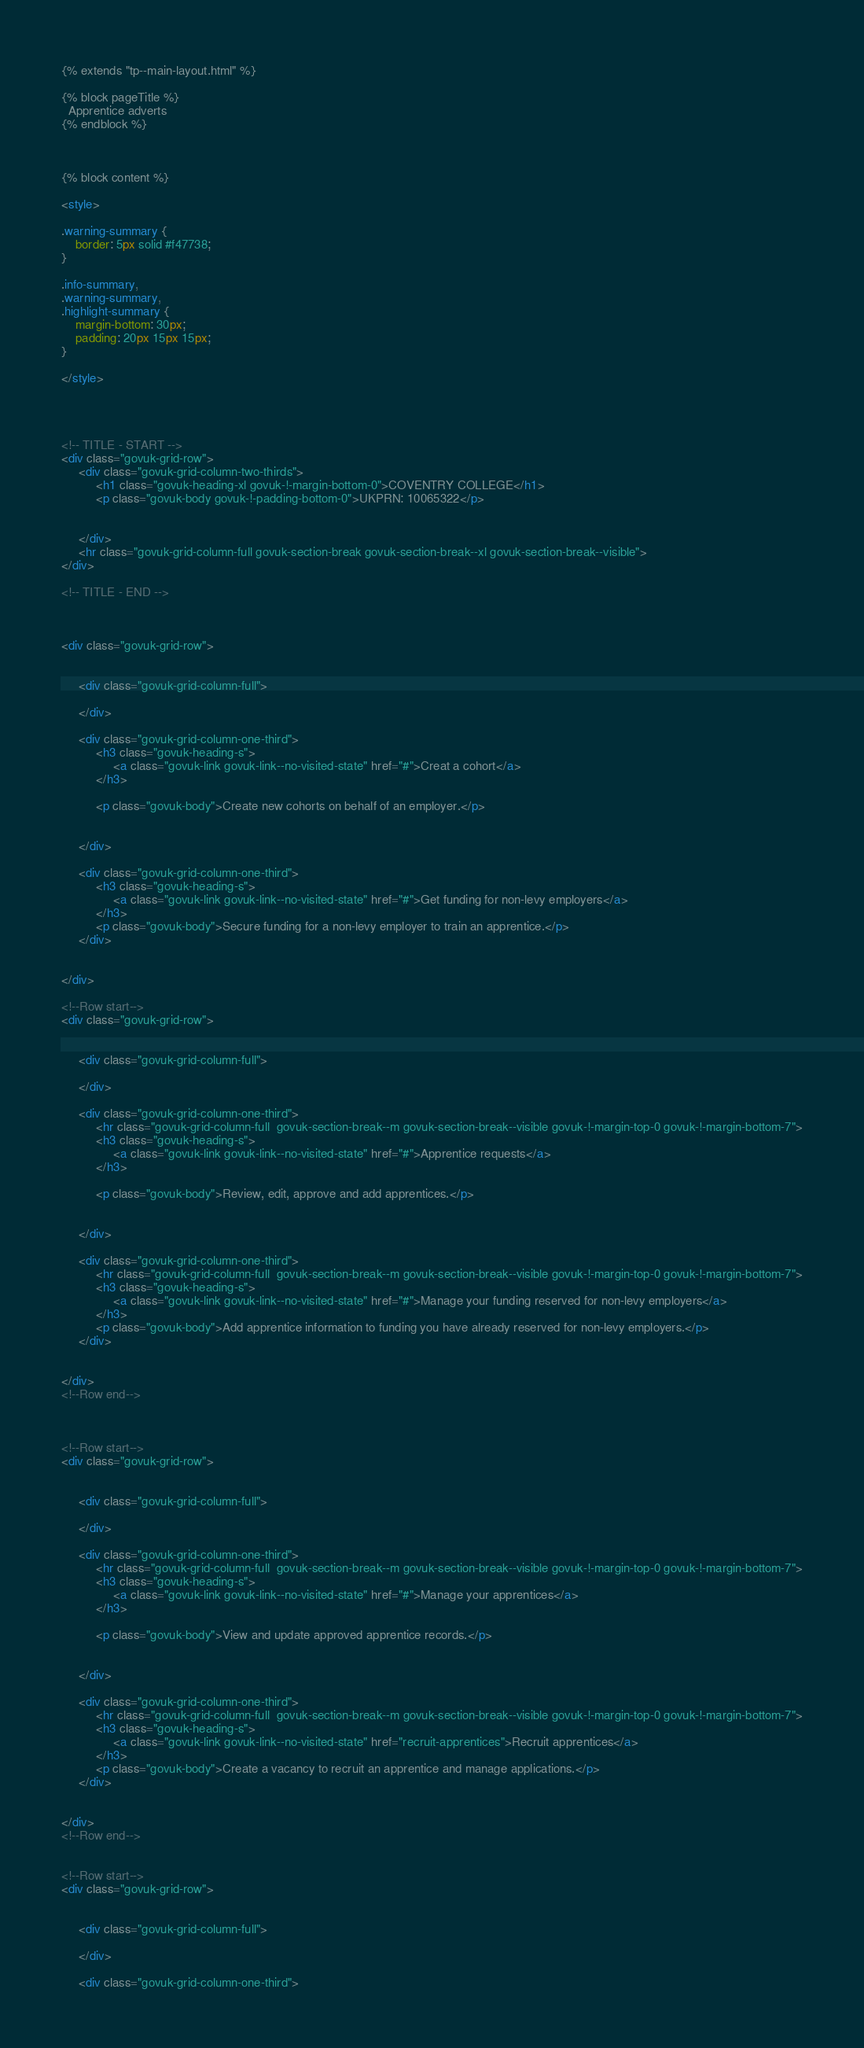Convert code to text. <code><loc_0><loc_0><loc_500><loc_500><_HTML_>{% extends "tp--main-layout.html" %}

{% block pageTitle %}
  Apprentice adverts
{% endblock %}



{% block content %}

<style>

.warning-summary {
    border: 5px solid #f47738;
}

.info-summary,
.warning-summary,
.highlight-summary {
    margin-bottom: 30px;
    padding: 20px 15px 15px;
}

</style>




<!-- TITLE - START -->
<div class="govuk-grid-row">
     <div class="govuk-grid-column-two-thirds">
          <h1 class="govuk-heading-xl govuk-!-margin-bottom-0">COVENTRY COLLEGE</h1>
          <p class="govuk-body govuk-!-padding-bottom-0">UKPRN: 10065322</p>
               
          
     </div>
     <hr class="govuk-grid-column-full govuk-section-break govuk-section-break--xl govuk-section-break--visible">
</div>

<!-- TITLE - END -->



<div class="govuk-grid-row">
     

     <div class="govuk-grid-column-full">
         
     </div>

     <div class="govuk-grid-column-one-third">
          <h3 class="govuk-heading-s">
               <a class="govuk-link govuk-link--no-visited-state" href="#">Creat a cohort</a>
          </h3>

          <p class="govuk-body">Create new cohorts on behalf of an employer.</p>

          
     </div>

     <div class="govuk-grid-column-one-third">
          <h3 class="govuk-heading-s">
               <a class="govuk-link govuk-link--no-visited-state" href="#">Get funding for non-levy employers</a>
          </h3>
          <p class="govuk-body">Secure funding for a non-levy employer to train an apprentice.</p>
     </div>
    

</div>

<!--Row start-->
<div class="govuk-grid-row">
     

     <div class="govuk-grid-column-full">
         
     </div>

     <div class="govuk-grid-column-one-third">
          <hr class="govuk-grid-column-full  govuk-section-break--m govuk-section-break--visible govuk-!-margin-top-0 govuk-!-margin-bottom-7">
          <h3 class="govuk-heading-s">
               <a class="govuk-link govuk-link--no-visited-state" href="#">Apprentice requests</a>
          </h3>

          <p class="govuk-body">Review, edit, approve and add apprentices.</p>

          
     </div>

     <div class="govuk-grid-column-one-third">
          <hr class="govuk-grid-column-full  govuk-section-break--m govuk-section-break--visible govuk-!-margin-top-0 govuk-!-margin-bottom-7">
          <h3 class="govuk-heading-s">
               <a class="govuk-link govuk-link--no-visited-state" href="#">Manage your funding reserved for non-levy employers</a>
          </h3>
          <p class="govuk-body">Add apprentice information to funding you have already reserved for non-levy employers.</p>
     </div>
    

</div>
<!--Row end-->



<!--Row start-->
<div class="govuk-grid-row">
     

     <div class="govuk-grid-column-full">
         
     </div>

     <div class="govuk-grid-column-one-third">
          <hr class="govuk-grid-column-full  govuk-section-break--m govuk-section-break--visible govuk-!-margin-top-0 govuk-!-margin-bottom-7">
          <h3 class="govuk-heading-s">
               <a class="govuk-link govuk-link--no-visited-state" href="#">Manage your apprentices</a>
          </h3>

          <p class="govuk-body">View and update approved apprentice records.</p>

          
     </div>

     <div class="govuk-grid-column-one-third">
          <hr class="govuk-grid-column-full  govuk-section-break--m govuk-section-break--visible govuk-!-margin-top-0 govuk-!-margin-bottom-7">
          <h3 class="govuk-heading-s">
               <a class="govuk-link govuk-link--no-visited-state" href="recruit-apprentices">Recruit apprentices</a>
          </h3>
          <p class="govuk-body">Create a vacancy to recruit an apprentice and manage applications.</p>
     </div>
    

</div>
<!--Row end-->


<!--Row start-->
<div class="govuk-grid-row">
     

     <div class="govuk-grid-column-full">
         
     </div>

     <div class="govuk-grid-column-one-third"></code> 